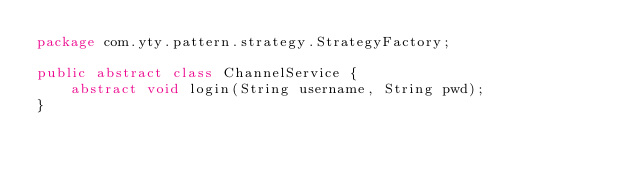Convert code to text. <code><loc_0><loc_0><loc_500><loc_500><_Java_>package com.yty.pattern.strategy.StrategyFactory;

public abstract class ChannelService {
    abstract void login(String username, String pwd);
}
</code> 